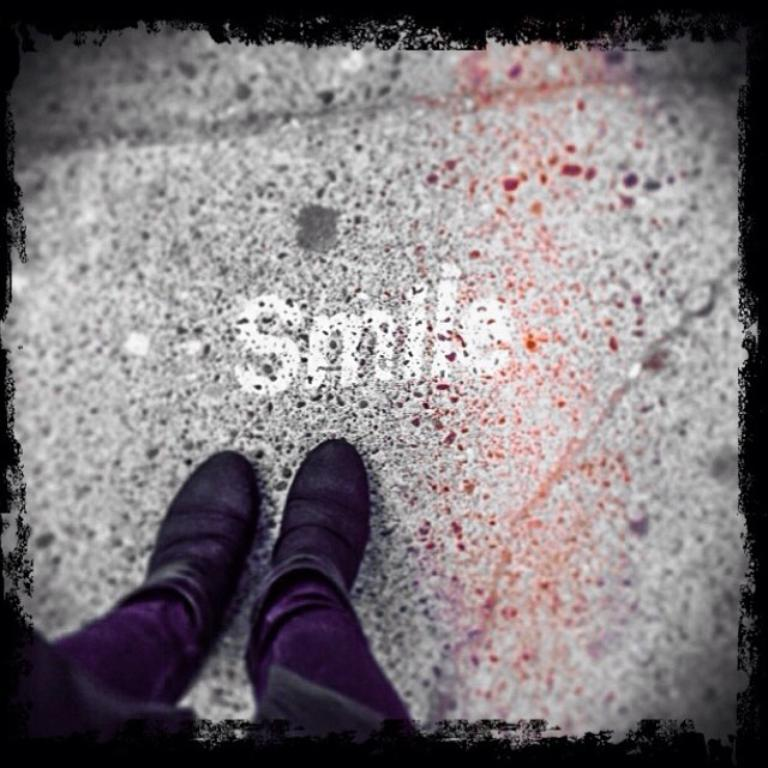What body parts are visible in the image? There are person's legs visible in the image. What else can be seen in the image besides the person's legs? There is some text in the image. What type of scent can be detected in the image? There is no mention of a scent in the image, so it cannot be determined from the image. 